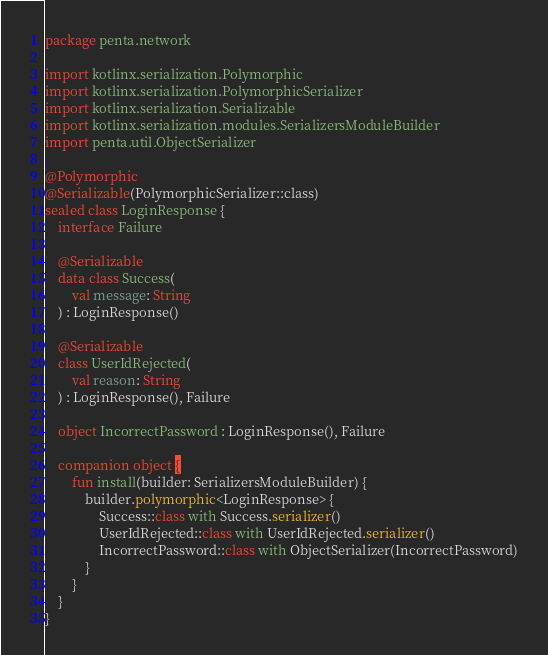<code> <loc_0><loc_0><loc_500><loc_500><_Kotlin_>package penta.network

import kotlinx.serialization.Polymorphic
import kotlinx.serialization.PolymorphicSerializer
import kotlinx.serialization.Serializable
import kotlinx.serialization.modules.SerializersModuleBuilder
import penta.util.ObjectSerializer

@Polymorphic
@Serializable(PolymorphicSerializer::class)
sealed class LoginResponse {
    interface Failure

    @Serializable
    data class Success(
        val message: String
    ) : LoginResponse()

    @Serializable
    class UserIdRejected(
        val reason: String
    ) : LoginResponse(), Failure

    object IncorrectPassword : LoginResponse(), Failure

    companion object {
        fun install(builder: SerializersModuleBuilder) {
            builder.polymorphic<LoginResponse> {
                Success::class with Success.serializer()
                UserIdRejected::class with UserIdRejected.serializer()
                IncorrectPassword::class with ObjectSerializer(IncorrectPassword)
            }
        }
    }
}</code> 